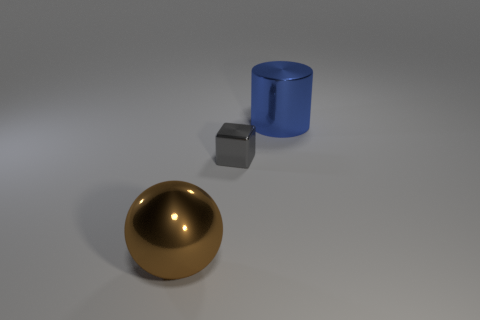Add 3 tiny gray metal blocks. How many objects exist? 6 Subtract all cylinders. How many objects are left? 2 Subtract 1 cylinders. How many cylinders are left? 0 Subtract all gray balls. Subtract all gray cylinders. How many balls are left? 1 Subtract all red cubes. How many brown cylinders are left? 0 Subtract all large brown objects. Subtract all brown metal things. How many objects are left? 1 Add 2 gray metallic blocks. How many gray metallic blocks are left? 3 Add 3 blue rubber cylinders. How many blue rubber cylinders exist? 3 Subtract 0 blue cubes. How many objects are left? 3 